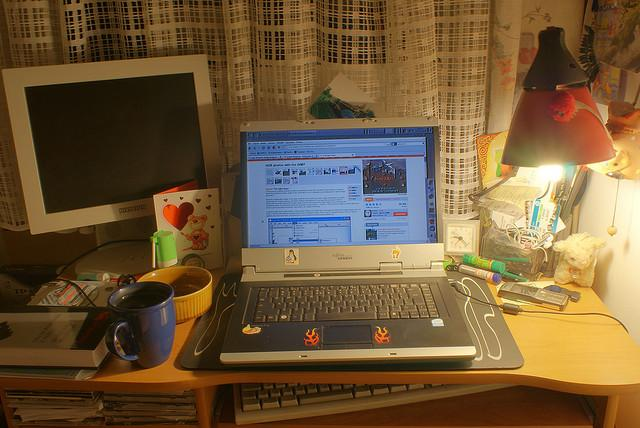How many keys are on a keyboard? Please explain your reasoning. 101. A typical keyboard has this many on it. 